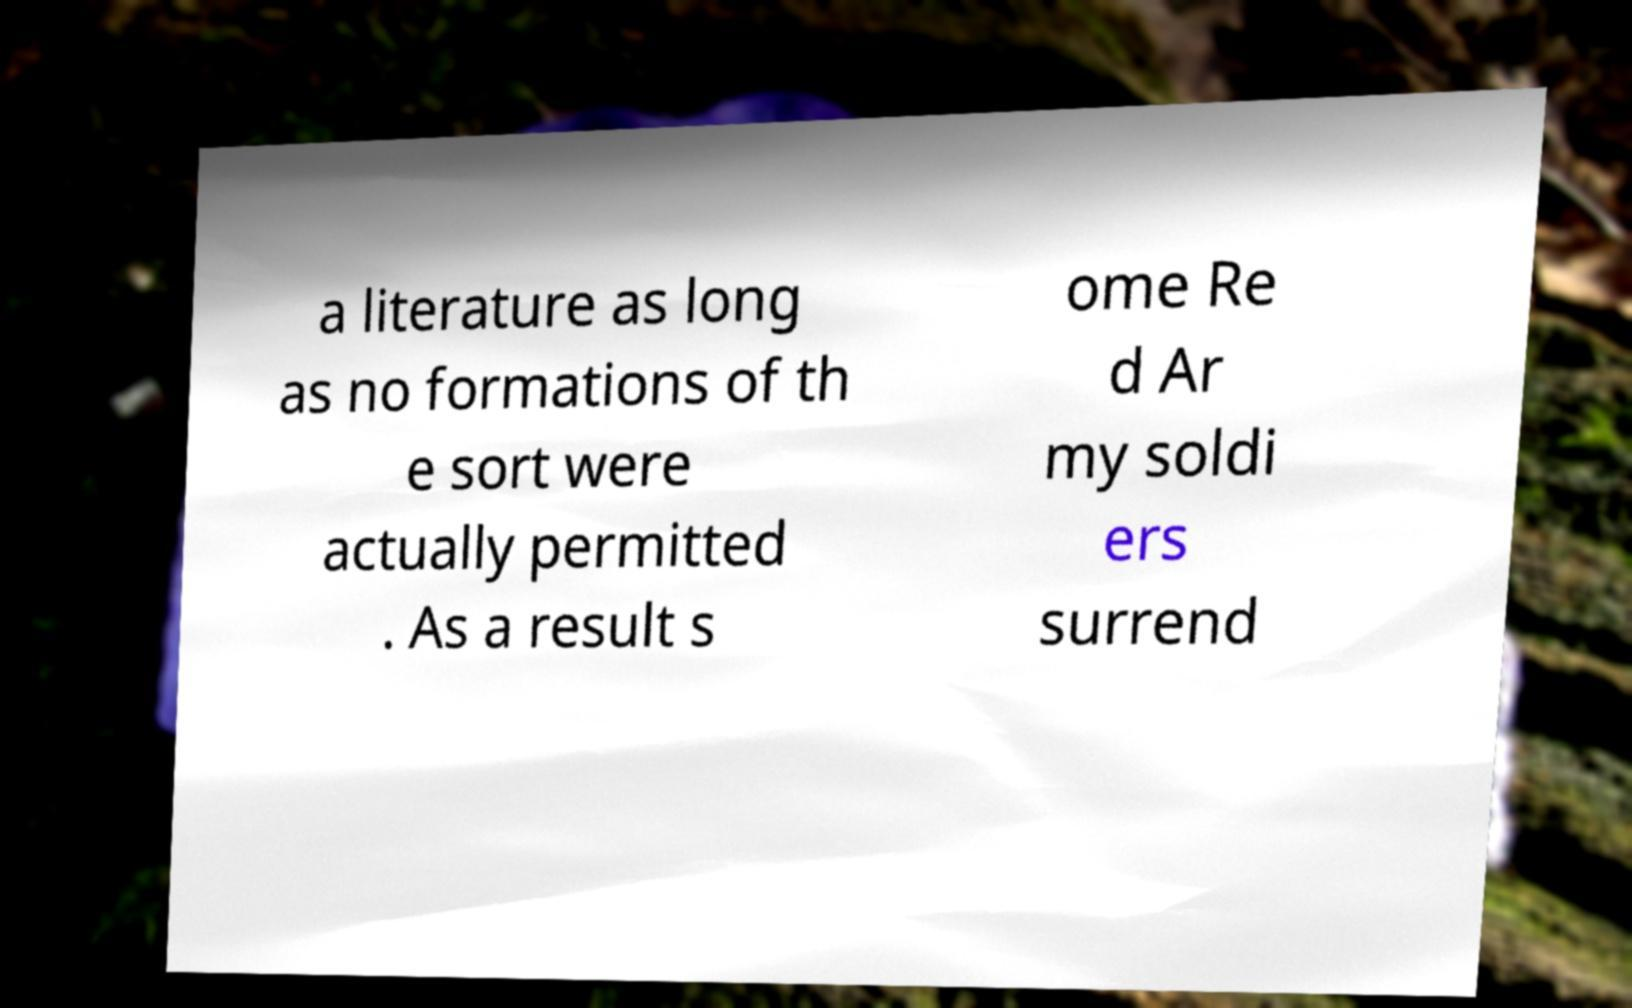I need the written content from this picture converted into text. Can you do that? a literature as long as no formations of th e sort were actually permitted . As a result s ome Re d Ar my soldi ers surrend 